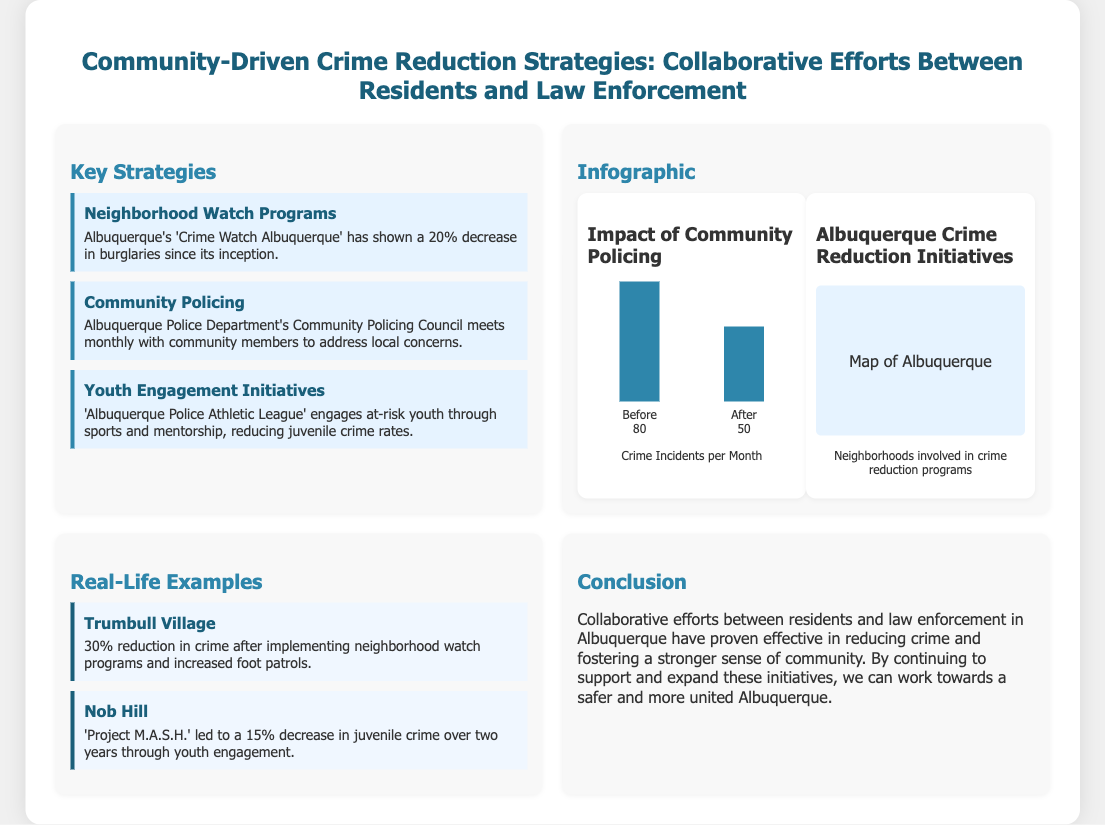What is the title of the presentation? The title is prominently displayed at the top of the slide, summarizing the main topic of the document.
Answer: Community-Driven Crime Reduction Strategies: Collaborative Efforts Between Residents and Law Enforcement What percentage decrease in burglaries is noted for 'Crime Watch Albuquerque'? The document specifies the percentage decrease in burglaries associated with the community program, which reflects its success.
Answer: 20% How often does the Albuquerque Police Department's Community Policing Council meet with community members? The meeting frequency is mentioned in the context of how the police engage with the community to address concerns.
Answer: Monthly What was the crime reduction in Trumbull Village after implementing neighborhood watch programs? The slide provides a specific statistic regarding the effectiveness of neighborhood watch programs in one community.
Answer: 30% What initiative reduced juvenile crime by 15% in Nob Hill? The document identifies a specific program and its impact on juvenile crime rates, showcasing effective strategies.
Answer: Project M.A.S.H What was the average number of crime incidents per month before community policing? The presentation includes data reflecting crime rates before the implementation of community-focused strategies.
Answer: 80 What is one real-life example mentioned showing successful community crime reduction? The slide highlights specific neighborhoods and their strategies as examples of successful collaborations in crime reduction.
Answer: Trumbull Village How are neighborhoods involved in crime reduction programs represented in the infographic? The presence of a visual element indicates the geographical aspect of the community-driven strategies discussed.
Answer: Map of Albuquerque 